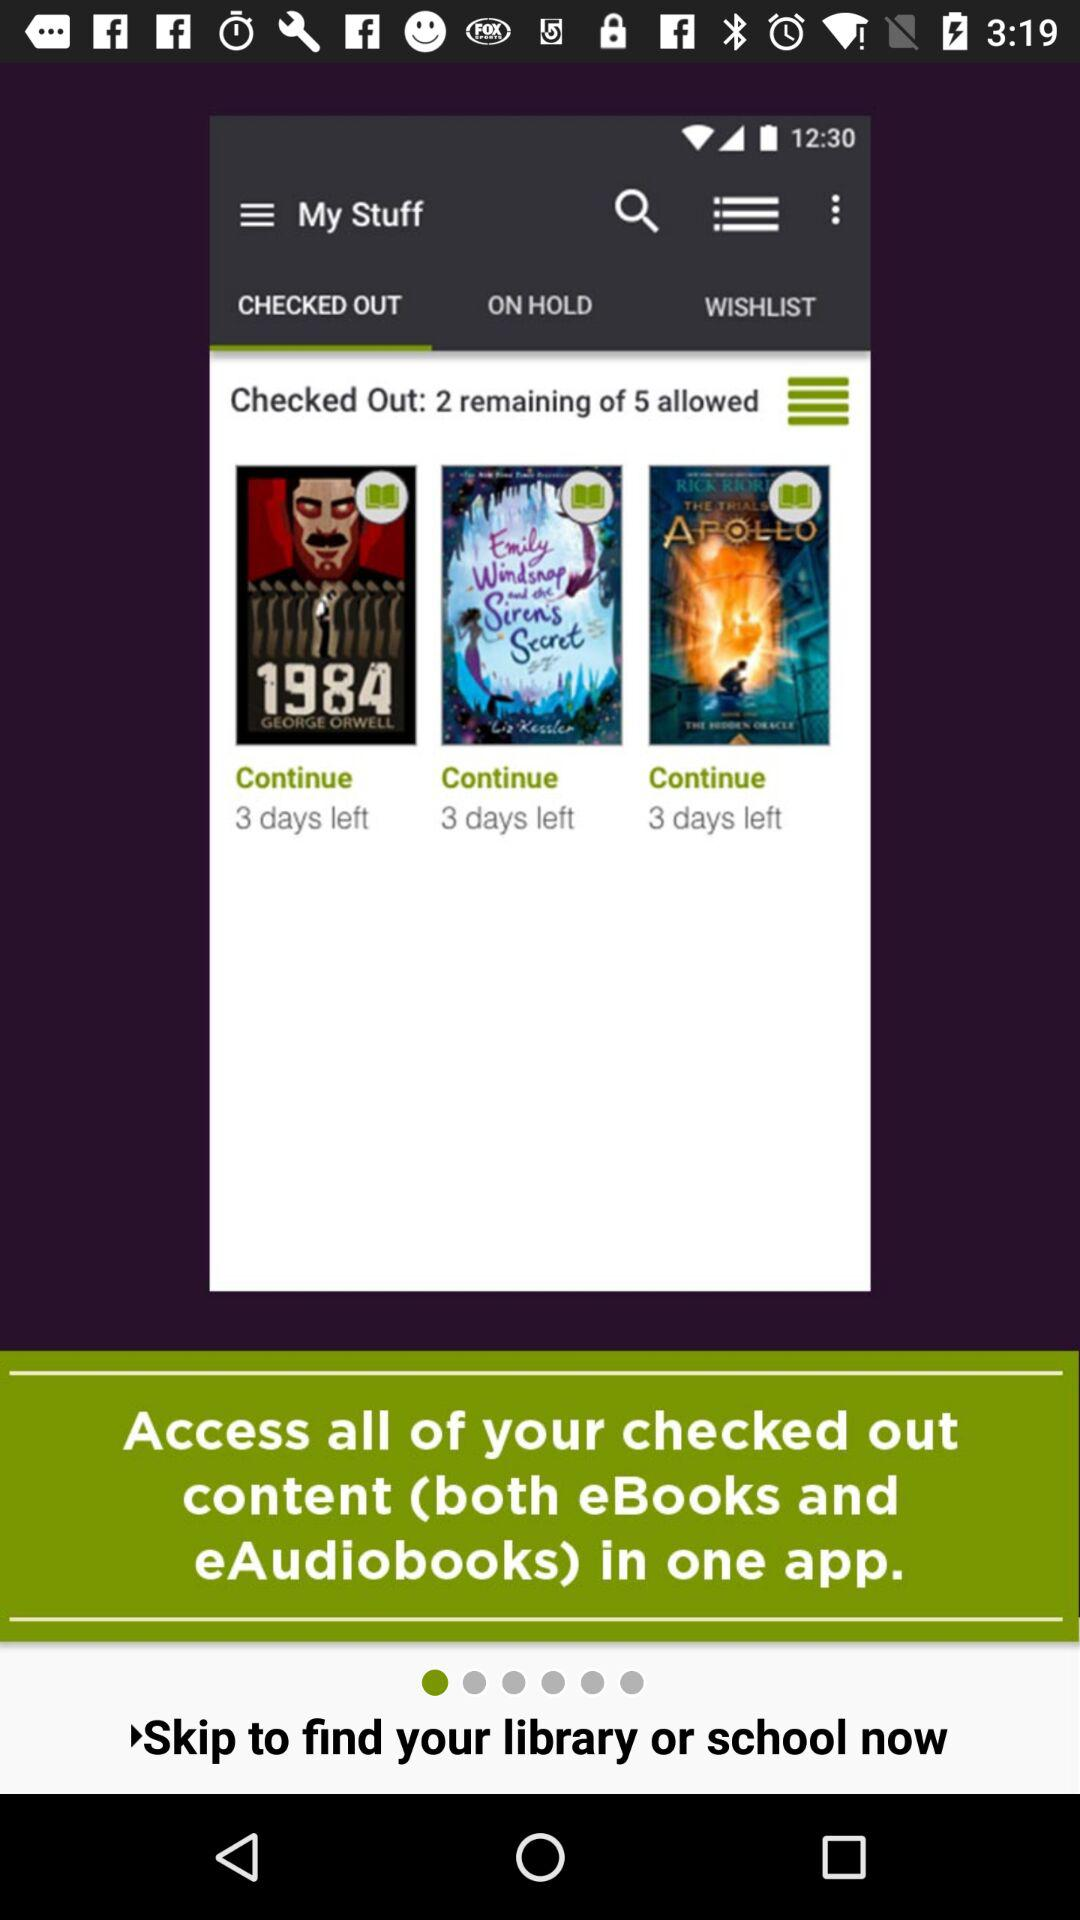How many days are left on the item with the longest remaining time?
Answer the question using a single word or phrase. 3 days 